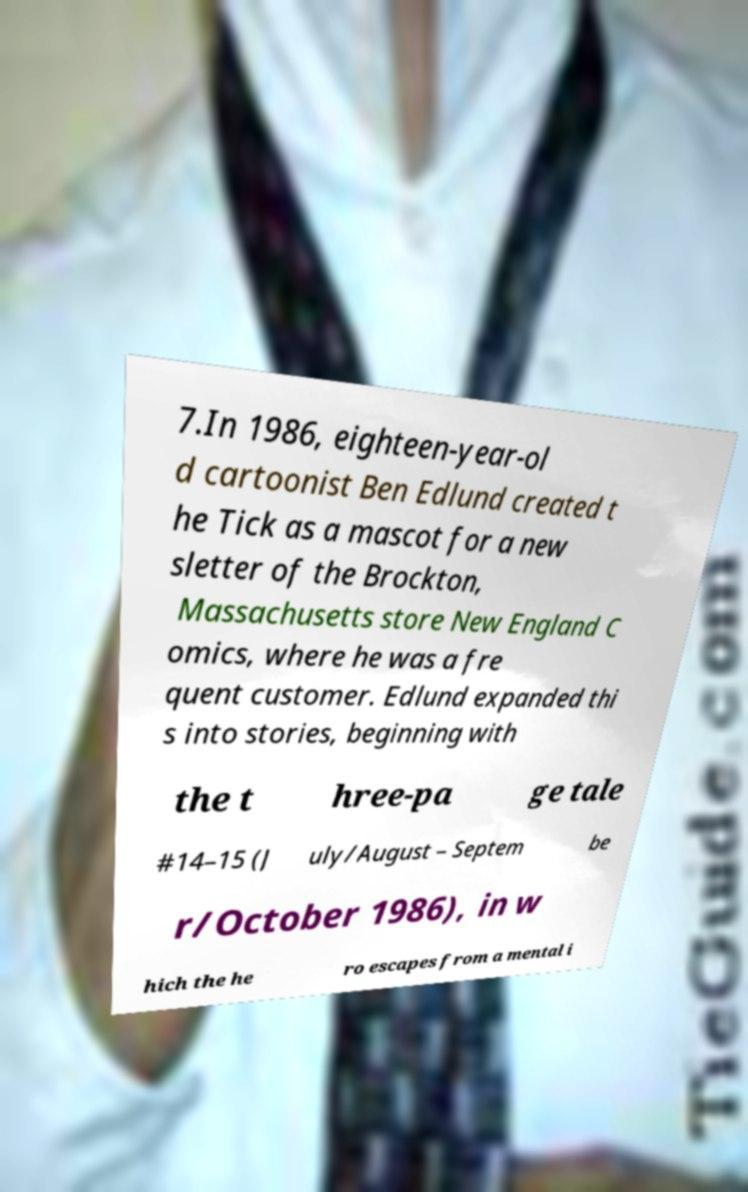What messages or text are displayed in this image? I need them in a readable, typed format. 7.In 1986, eighteen-year-ol d cartoonist Ben Edlund created t he Tick as a mascot for a new sletter of the Brockton, Massachusetts store New England C omics, where he was a fre quent customer. Edlund expanded thi s into stories, beginning with the t hree-pa ge tale #14–15 (J uly/August – Septem be r/October 1986), in w hich the he ro escapes from a mental i 